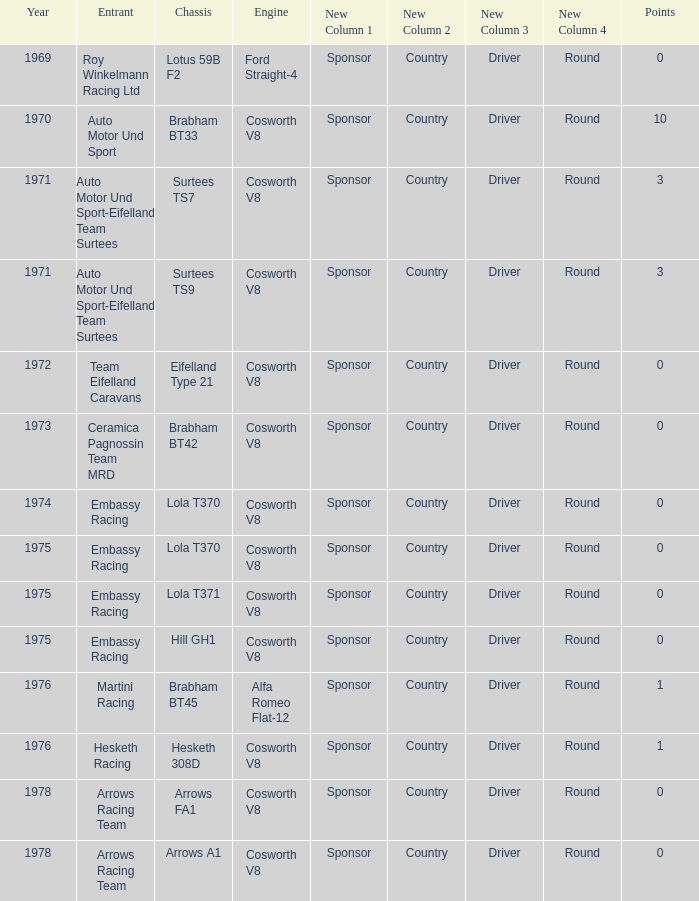What was the total amount of points in 1978 with a Chassis of arrows fa1? 0.0. 